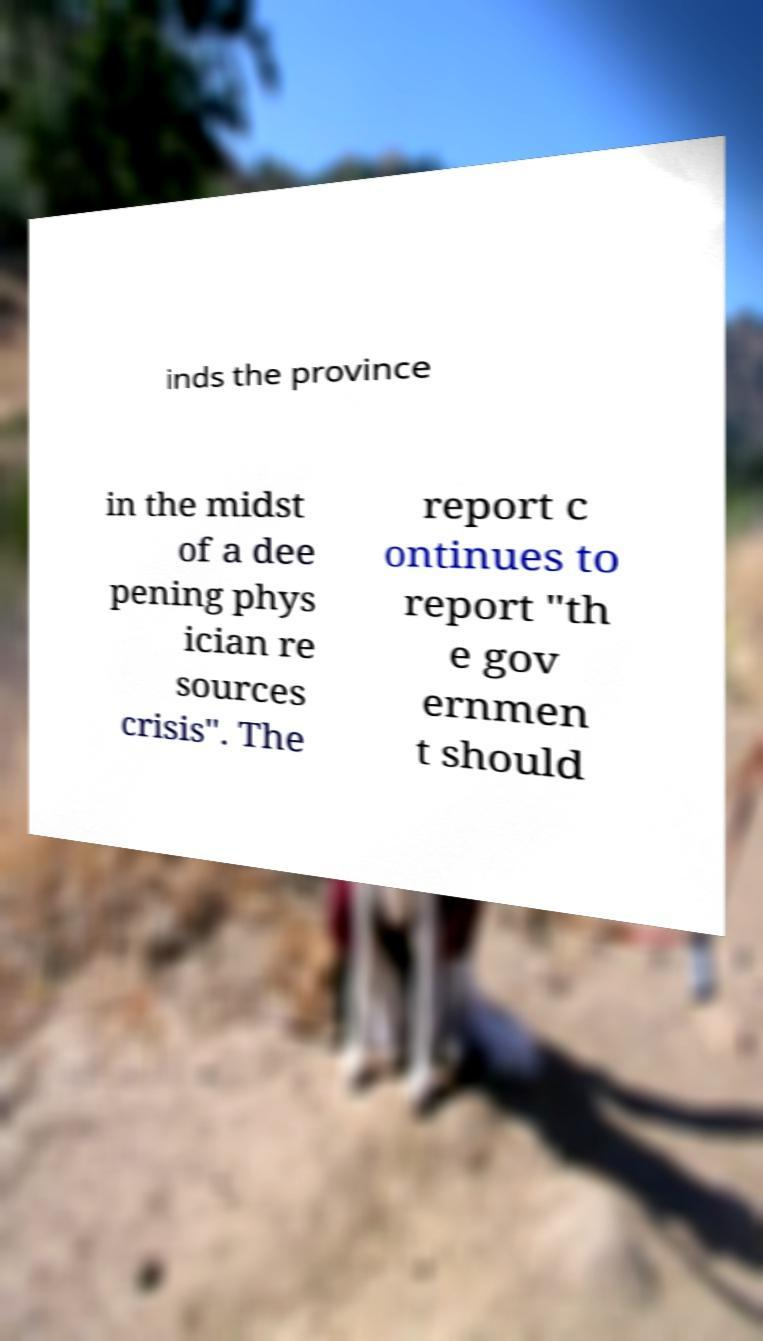Could you extract and type out the text from this image? inds the province in the midst of a dee pening phys ician re sources crisis". The report c ontinues to report "th e gov ernmen t should 